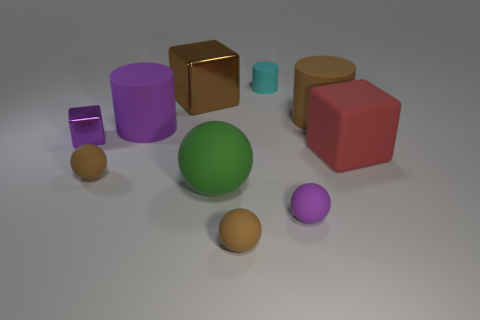How many big rubber cubes have the same color as the tiny metal block?
Provide a short and direct response. 0. Is there any other thing that has the same shape as the purple shiny thing?
Provide a short and direct response. Yes. Is there a rubber object behind the tiny sphere to the right of the tiny brown matte thing that is right of the big brown metallic thing?
Your response must be concise. Yes. What number of purple cubes have the same material as the cyan cylinder?
Make the answer very short. 0. There is a purple object that is in front of the matte block; does it have the same size as the purple matte object behind the large red matte object?
Offer a terse response. No. There is a block on the left side of the rubber cylinder left of the small thing in front of the small purple matte thing; what color is it?
Give a very brief answer. Purple. Is there another tiny rubber object that has the same shape as the tiny cyan rubber thing?
Ensure brevity in your answer.  No. Are there an equal number of brown cylinders that are on the left side of the purple rubber cylinder and large red rubber blocks that are left of the small metallic cube?
Keep it short and to the point. Yes. Does the purple object in front of the large green ball have the same shape as the large brown rubber object?
Provide a succinct answer. No. Is the shape of the large red rubber thing the same as the large metallic thing?
Offer a very short reply. Yes. 